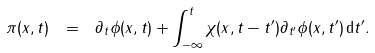Convert formula to latex. <formula><loc_0><loc_0><loc_500><loc_500>\pi ( x , t ) \ = \ \partial _ { t } \phi ( x , t ) + \int _ { - \infty } ^ { t } \chi ( x , t - t ^ { \prime } ) \partial _ { t ^ { \prime } } \phi ( x , t ^ { \prime } ) \, \mathrm d t ^ { \prime } .</formula> 